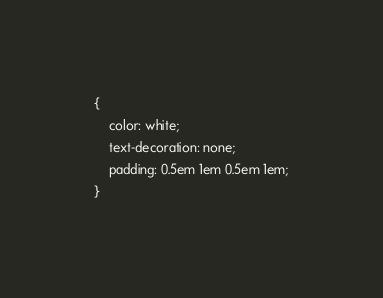<code> <loc_0><loc_0><loc_500><loc_500><_HTML_>{
    color: white;
    text-decoration: none;
    padding: 0.5em 1em 0.5em 1em;
}
</code> 